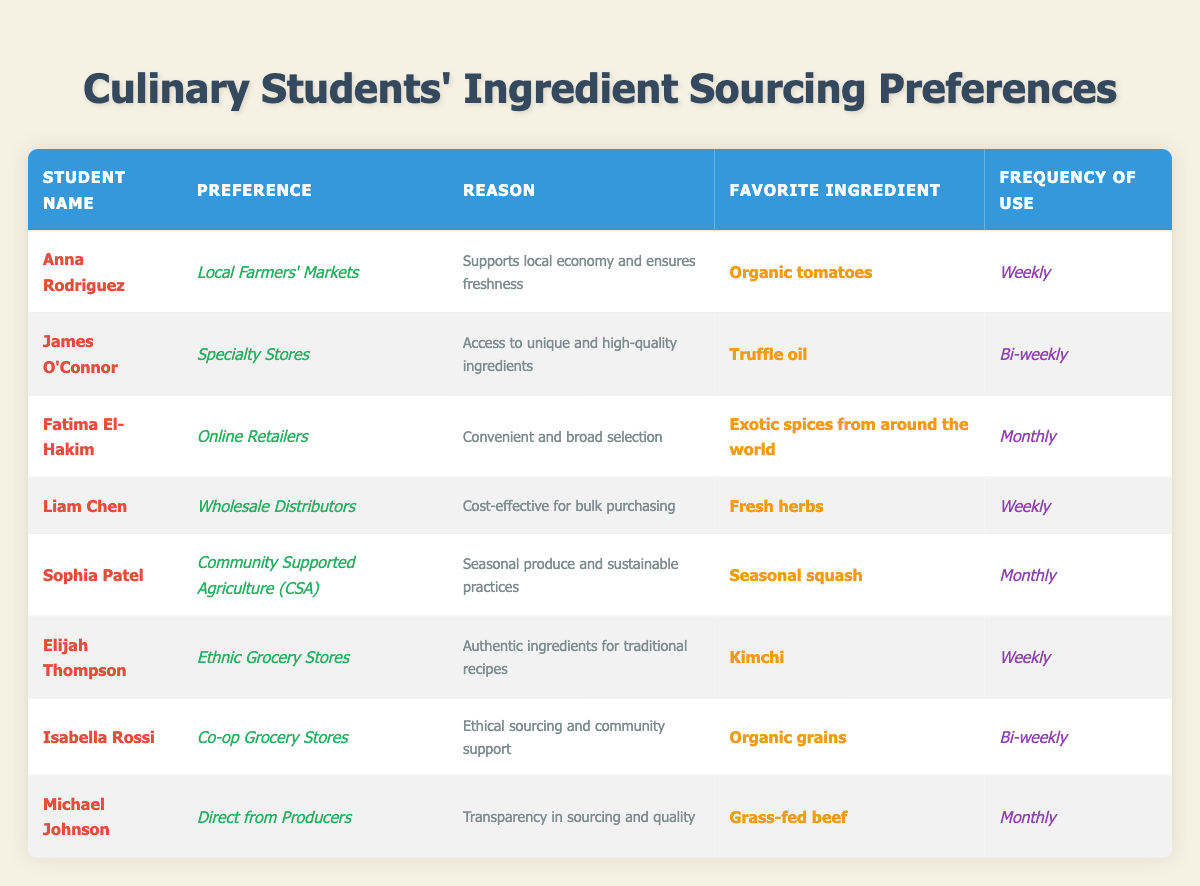What is Anna Rodriguez's favorite ingredient? The table describes Anna Rodriguez's preferences under the 'Favorite Ingredient' column, where it states that her favorite ingredient is 'Organic tomatoes.'
Answer: Organic tomatoes Which student prefers online retailers for ingredient sourcing? By scanning the table rows under the 'Preference' column, Fatima El-Hakim is identified as the student who prefers 'Online Retailers.'
Answer: Fatima El-Hakim How often does Elijah Thompson source ingredients from ethnic grocery stores? The table specifies the frequency of sourcing ingredients in the 'Frequency of Use' column; for Elijah Thompson, it is 'Weekly.'
Answer: Weekly What are the top two preferences for ingredient sourcing among the students? Looking at the 'Preference' column, the two most cited preferences are 'Local Farmers' Markets' and 'Wholesale Distributors,' held by Anna Rodriguez and Liam Chen, respectively.
Answer: Local Farmers' Markets and Wholesale Distributors Do any students source ingredients from community supported agriculture? By reviewing the table, it is clear that Sophia Patel sources from 'Community Supported Agriculture (CSA).'
Answer: Yes Count the number of students who prefer to source ingredients weekly. There are four students who have 'Weekly' as their frequency of use: Anna Rodriguez, Liam Chen, Elijah Thompson, and James O'Connor. The total is 4.
Answer: 4 Is truffle oil James O'Connor's favorite ingredient? By checking the 'Favorite Ingredient' column for James O'Connor, it confirms that his favorite ingredient is indeed 'Truffle oil.'
Answer: Yes What is the reason given by Isabella Rossi for choosing co-op grocery stores? The table provides the reason for Isabella Rossi's preference in the 'Reason' column, stating it is due to 'Ethical sourcing and community support.'
Answer: Ethical sourcing and community support Which ingredient is used most frequently by students who prefer local sourcing options? Anna Rodriguez and Elijah Thompson use their preferred sourcing methods weekly, choosing organic tomatoes and kimchi, respectively. There are two ingredients.
Answer: Organic tomatoes and kimchi Who prefers to source ingredients directly from producers? The table indicates that Michael Johnson prefers to source ingredients 'Direct from Producers.'
Answer: Michael Johnson 